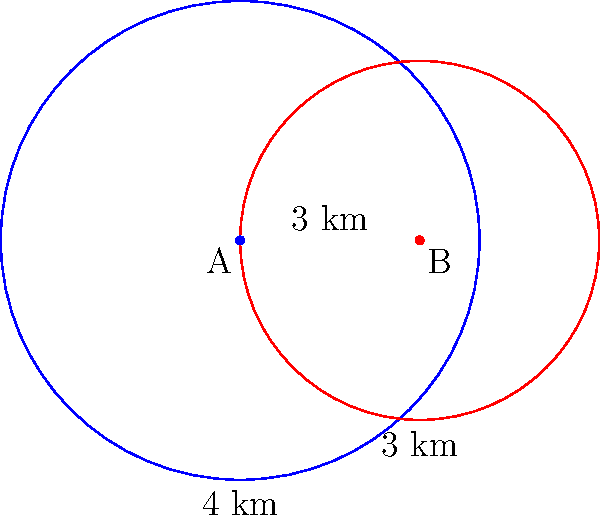Two circular surveillance zones are set up in a border region. Zone A has a radius of 4 km, and Zone B has a radius of 3 km. The centers of these zones are 3 km apart. Calculate the area of the overlapping region between these two surveillance zones. Round your answer to the nearest square kilometer. To find the area of overlap between two circles, we need to use the formula for the area of intersection of two circles. Let's approach this step-by-step:

1) First, we need to calculate the distance between the centers (d) and the radii (r1 and r2):
   d = 3 km, r1 = 4 km, r2 = 3 km

2) Now, we need to calculate the angles α and β using the law of cosines:

   $\cos(\alpha/2) = \frac{r_1^2 + d^2 - r_2^2}{2r_1d}$
   $\cos(\beta/2) = \frac{r_2^2 + d^2 - r_1^2}{2r_2d}$

3) Plugging in the values:

   $\cos(\alpha/2) = \frac{4^2 + 3^2 - 3^2}{2 * 4 * 3} = \frac{16}{24} = \frac{2}{3}$
   $\cos(\beta/2) = \frac{3^2 + 3^2 - 4^2}{2 * 3 * 3} = \frac{2}{6} = \frac{1}{3}$

4) Taking the inverse cosine:

   $\alpha = 2 * \arccos(\frac{2}{3}) \approx 1.8312$ radians
   $\beta = 2 * \arccos(\frac{1}{3}) \approx 2.5447$ radians

5) The area of overlap is given by:

   $A = r_1^2(\alpha - \sin\alpha) + r_2^2(\beta - \sin\beta)$

6) Substituting the values:

   $A = 4^2(1.8312 - \sin(1.8312)) + 3^2(2.5447 - \sin(2.5447))$
   $A \approx 16(1.8312 - 0.9628) + 9(2.5447 - 0.8019)$
   $A \approx 16(0.8684) + 9(1.7428)$
   $A \approx 13.8944 + 15.6852$
   $A \approx 29.5796$ km²

7) Rounding to the nearest square kilometer:

   $A \approx 30$ km²
Answer: 30 km² 